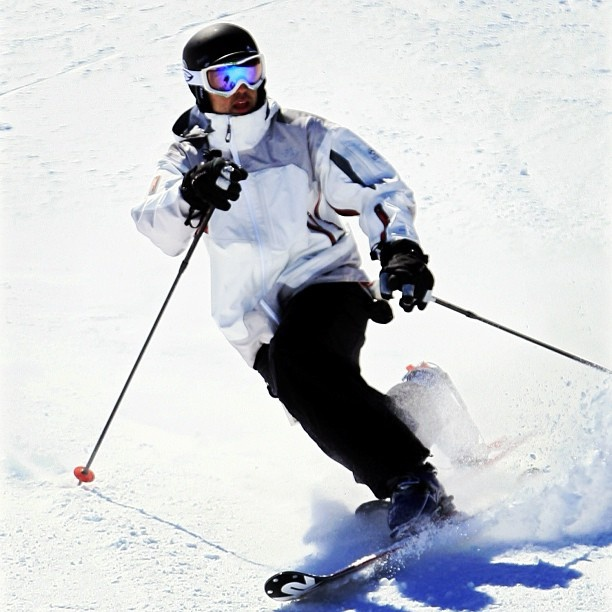Describe the objects in this image and their specific colors. I can see people in white, black, lightgray, and darkgray tones, snowboard in white, lightgray, blue, darkgray, and gray tones, and skis in white, lightgray, black, and gray tones in this image. 